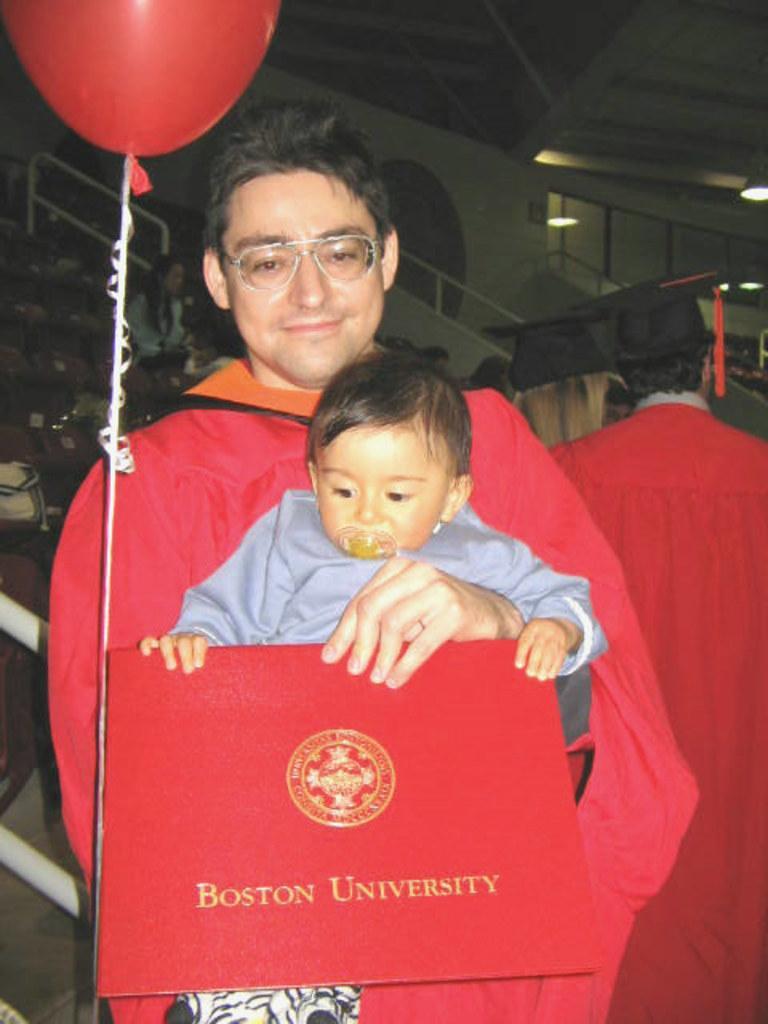In one or two sentences, can you explain what this image depicts? In the image we can see a man standing, wearing clothes and spectacles, and he is carrying a baby. This is a baby sucker, balloon, light and an object. Behind them there are other people wearing clothes. 